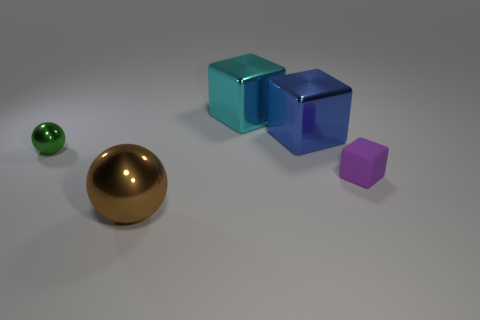There is a ball left of the big metallic thing that is in front of the thing to the left of the brown shiny sphere; what size is it?
Make the answer very short. Small. Is there a cyan object that is to the right of the large thing that is in front of the tiny purple object?
Your answer should be compact. Yes. How many tiny purple blocks are right of the big cube on the right side of the large cyan cube that is to the right of the tiny green thing?
Provide a short and direct response. 1. What is the color of the object that is both behind the brown metallic object and in front of the green metallic ball?
Your response must be concise. Purple. What number of cubes are either big cyan objects or purple things?
Offer a terse response. 2. What color is the block that is the same size as the cyan object?
Offer a terse response. Blue. Is there a matte block right of the large object in front of the tiny thing behind the tiny matte object?
Provide a succinct answer. Yes. The cyan thing has what size?
Make the answer very short. Large. What number of objects are either blue shiny cylinders or small objects?
Keep it short and to the point. 2. What is the color of the other cube that is the same material as the large blue block?
Ensure brevity in your answer.  Cyan. 